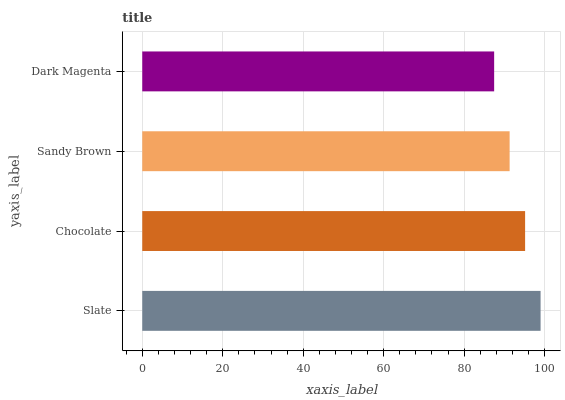Is Dark Magenta the minimum?
Answer yes or no. Yes. Is Slate the maximum?
Answer yes or no. Yes. Is Chocolate the minimum?
Answer yes or no. No. Is Chocolate the maximum?
Answer yes or no. No. Is Slate greater than Chocolate?
Answer yes or no. Yes. Is Chocolate less than Slate?
Answer yes or no. Yes. Is Chocolate greater than Slate?
Answer yes or no. No. Is Slate less than Chocolate?
Answer yes or no. No. Is Chocolate the high median?
Answer yes or no. Yes. Is Sandy Brown the low median?
Answer yes or no. Yes. Is Dark Magenta the high median?
Answer yes or no. No. Is Chocolate the low median?
Answer yes or no. No. 